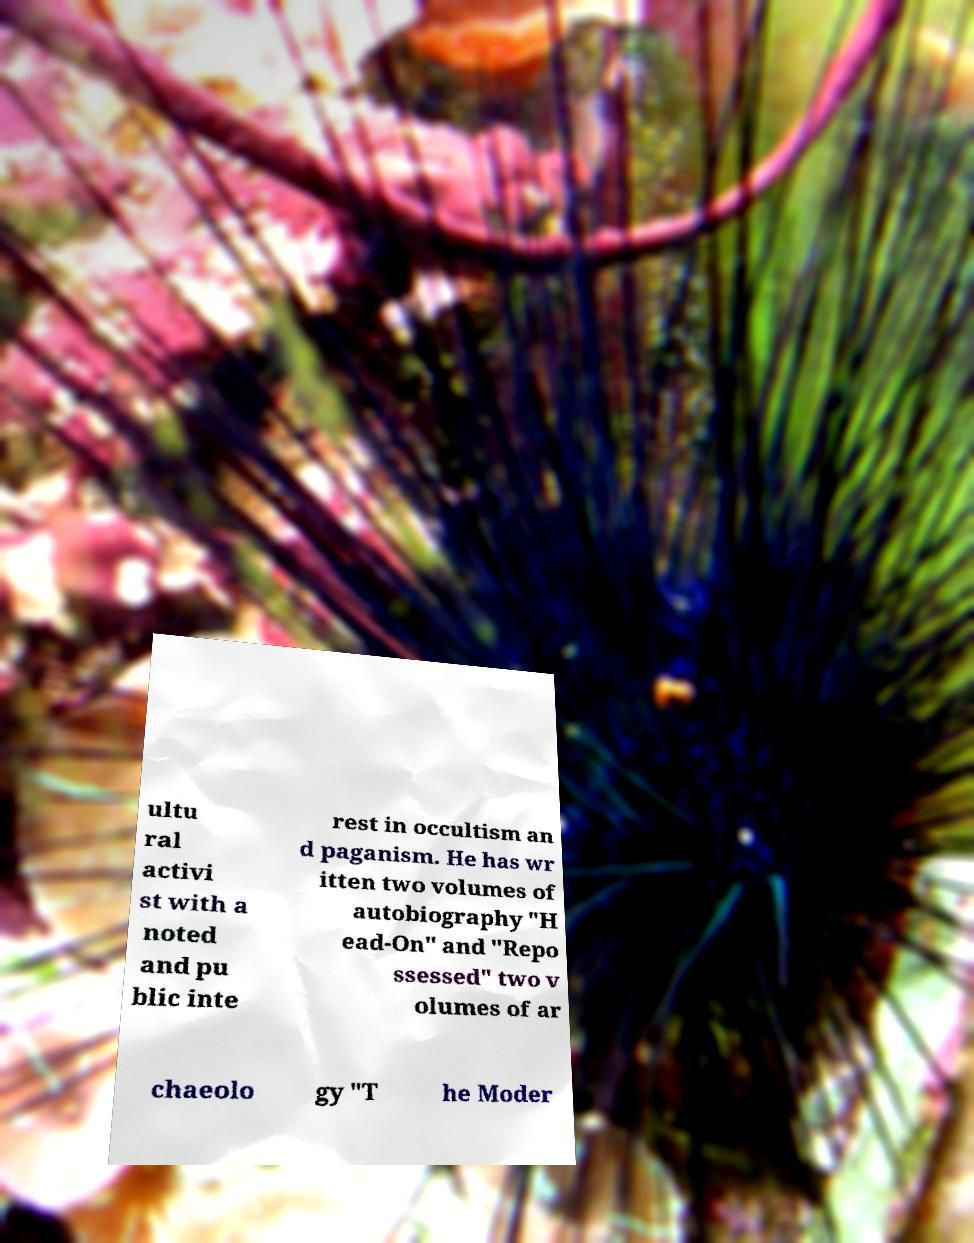Please identify and transcribe the text found in this image. ultu ral activi st with a noted and pu blic inte rest in occultism an d paganism. He has wr itten two volumes of autobiography "H ead-On" and "Repo ssessed" two v olumes of ar chaeolo gy "T he Moder 